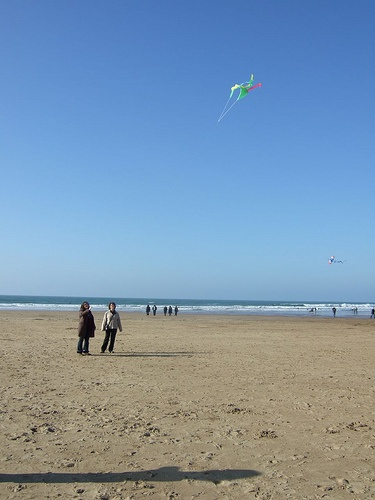Describe the objects in this image and their specific colors. I can see people in gray, black, and darkgray tones, people in gray, black, darkgray, and lightgray tones, kite in gray, teal, green, and turquoise tones, kite in gray, lightblue, and darkgray tones, and people in gray, black, and darkblue tones in this image. 